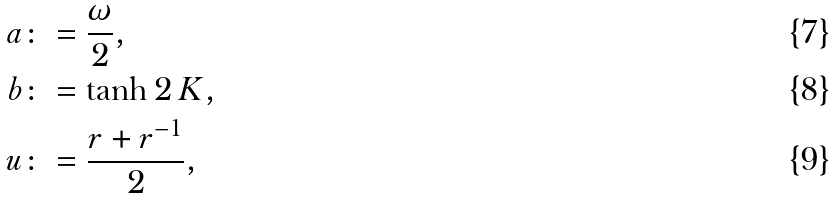<formula> <loc_0><loc_0><loc_500><loc_500>a & \colon = \frac { \omega } { 2 } , \\ b & \colon = \tanh 2 \, K , \\ u & \colon = \frac { r + r ^ { - 1 } } { 2 } ,</formula> 